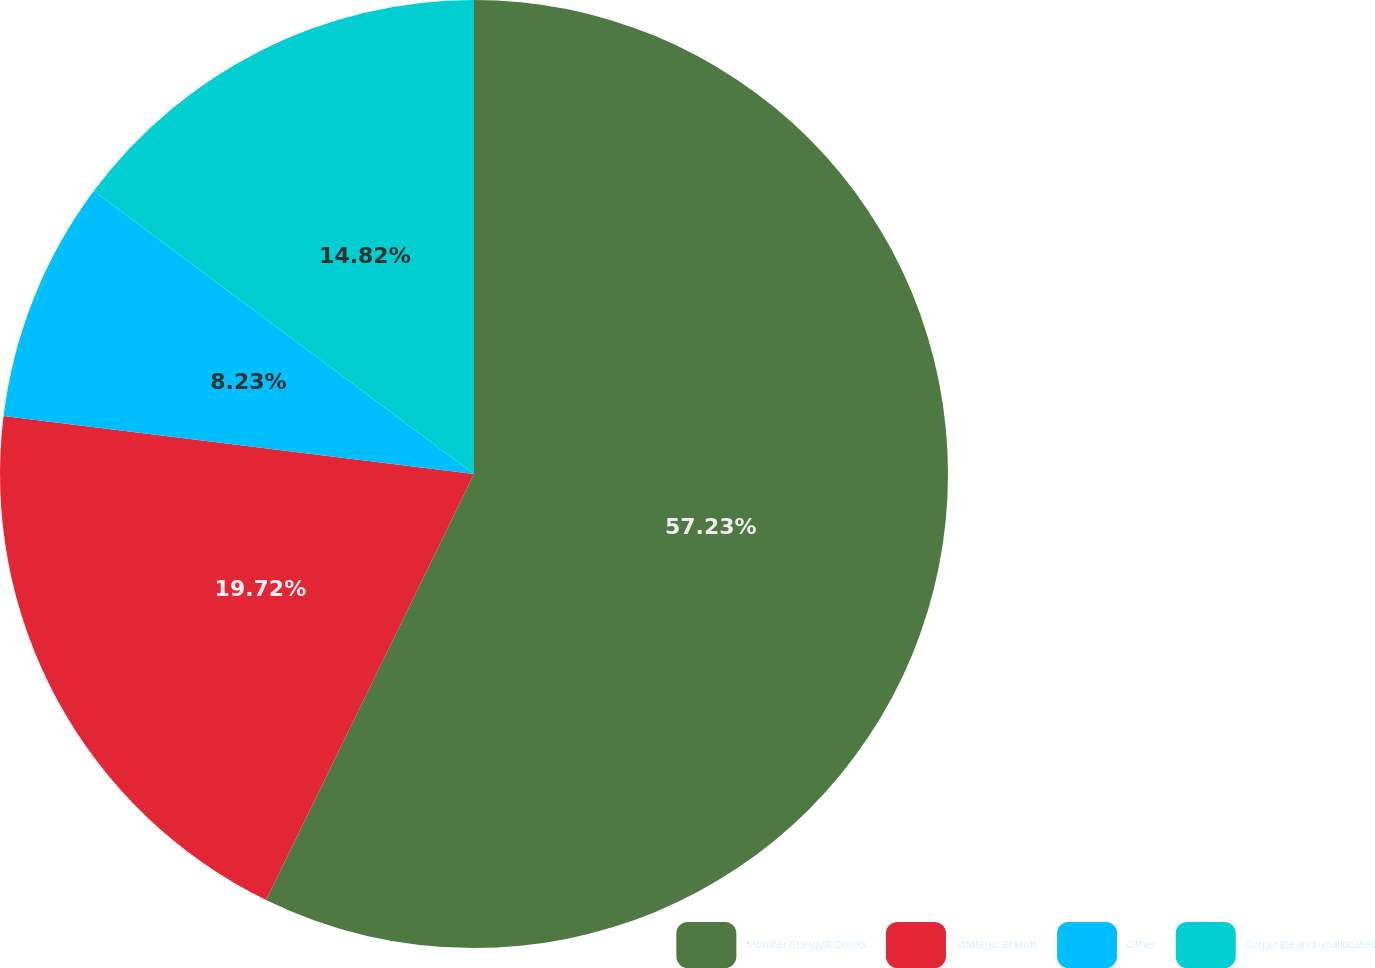<chart> <loc_0><loc_0><loc_500><loc_500><pie_chart><fcel>Monster Energy® Drinks<fcel>Strategic Brands<fcel>Other<fcel>Corporate and unallocated<nl><fcel>57.23%<fcel>19.72%<fcel>8.23%<fcel>14.82%<nl></chart> 